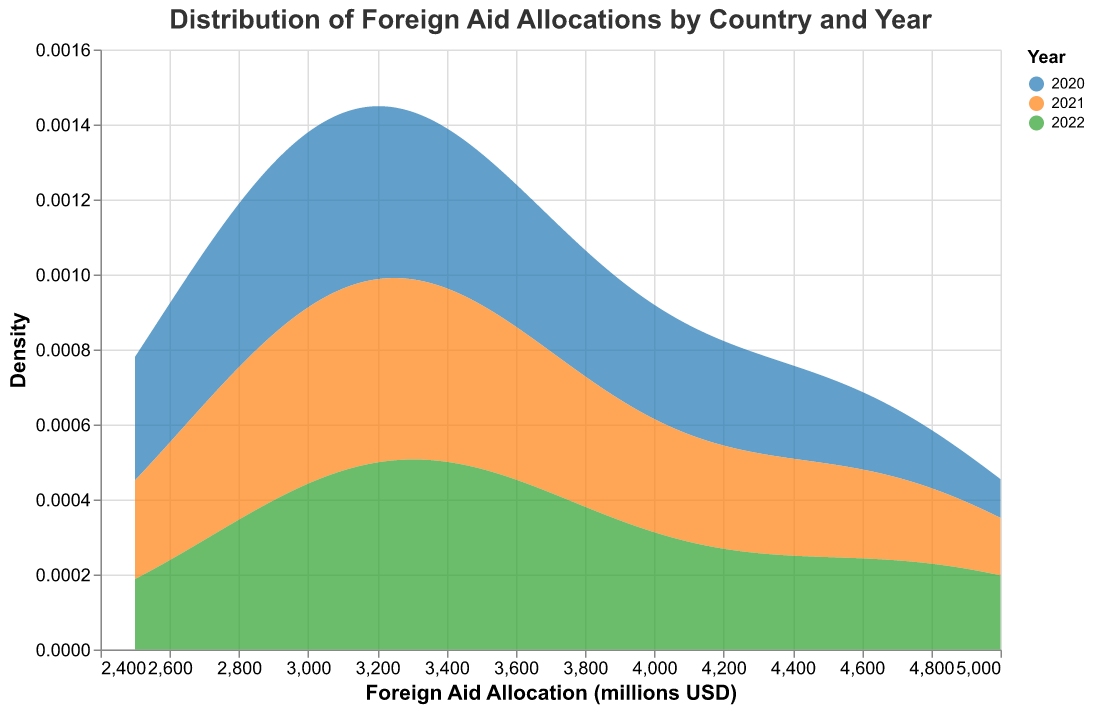What's the title of the figure? The title is usually displayed at the top of the figure. In this case, it states the overall topic of the figure.
Answer: Distribution of Foreign Aid Allocations by Country and Year What does the x-axis represent in this figure? The x-axis is typically labeled at the bottom and provides detail on what the horizontal measurement quantifies, indicated by the label. Here it shows the Foreign Aid Allocation in millions of USD.
Answer: Foreign Aid Allocation (millions USD) Which colors represent each year in the figure? The legend identifies colors and their associated years. The colors provided are matched with their respective years.
Answer: 2020: blue, 2021: orange, 2022: green What does the y-axis represent? The y-axis label provides information on the vertical measurement which quantifies the value being plotted. In this plot, it represents the density of the Foreign Aid Allocation values.
Answer: Density How has the distribution of foreign aid allocations changed over the years? By comparing the density distributions for each year (different colors), we can see if the distributions have shifted, broadened, or changed shape from 2020 to 2022.
Answer: The distribution has slightly shifted upwards over the years Which year had the highest density at the lower range of Foreign Aid Allocation? By looking where the density peaks at the lower end of the x-axis, we see which year/color corresponds to the higher density value.
Answer: 2020 In which year did the Foreign Aid Allocation densities tend to be higher overall? We observe general trends in the densities for each year across all ranges of Foreign Aid Allocation, focusing on which year consistently shows higher density values across more of the x-axis.
Answer: 2022 What is the overall trend in foreign aid allocations from 2020 to 2022? By examining the direction in which the distributions shift over the three years, we get an idea of whether the allocations are increasing or decreasing.
Answer: The trend in Foreign Aid Allocation is increasing from 2020 to 2022 Between which years does the largest increase in Foreign Aid Allocation appear to occur? We compare the peaks of the density lines and see which two years show the most significant upward shift in distribution.
Answer: Between 2020 and 2021 Is there any single year where the distribution is significantly different than the others? By comparing the shapes and locations of the density plots for 2020, 2021, and 2022, we look for the year whose distribution stands out most compared to the others.
Answer: No, the distributions are somewhat consistent without a single year standing out remarkably What is the range of the Foreign Aid Allocation values represented in the figure? The x-axis shows the extent of Foreign Aid Allocation values that were included in the density plot, marked by the limits of the axis.
Answer: 2500 to 5000 millions USD 